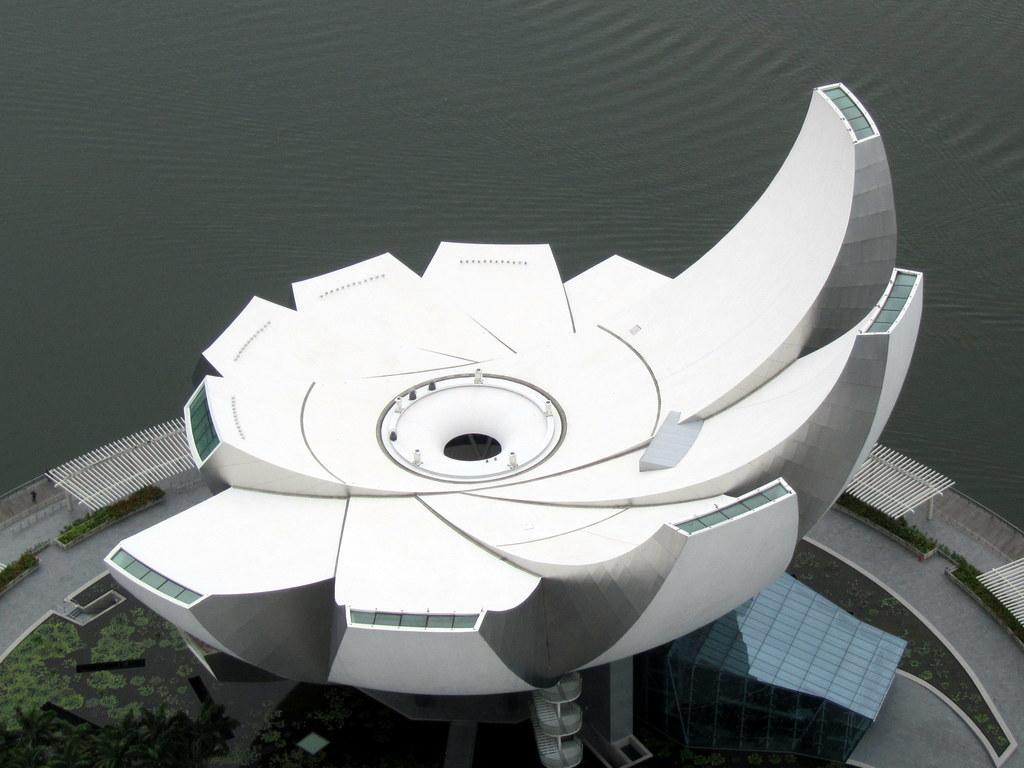Describe this image in one or two sentences. In this picture there is a building and there is a railing around the building. At the back there is water. At the bottom there is grass. 